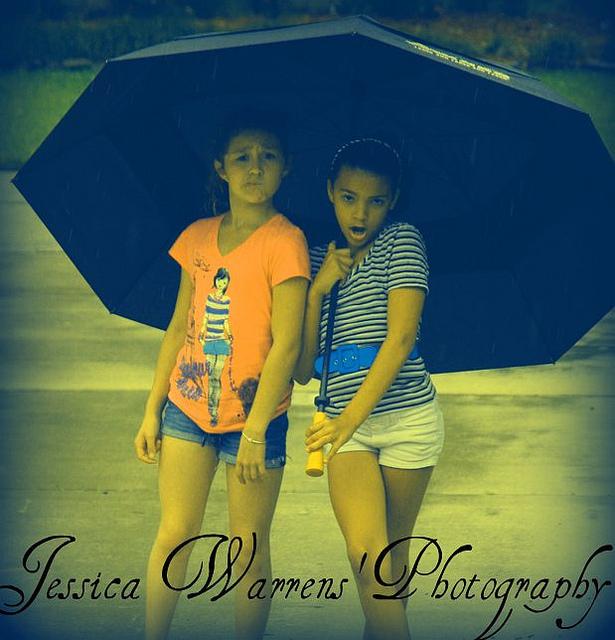Is this an oversized umbrella?
Write a very short answer. Yes. Do you think this picture was posed, or a candid shot?
Answer briefly. Posed. Are they happy?
Answer briefly. No. 